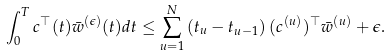Convert formula to latex. <formula><loc_0><loc_0><loc_500><loc_500>{ } \int _ { 0 } ^ { T } { c } ^ { \top } ( t ) \bar { w } ^ { ( \epsilon ) } ( t ) d t \leq \sum _ { u = 1 } ^ { N } \left ( t _ { u } - t _ { u - 1 } \right ) ( { c } ^ { ( u ) } ) ^ { \top } \bar { w } ^ { ( u ) } + \epsilon .</formula> 